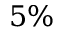Convert formula to latex. <formula><loc_0><loc_0><loc_500><loc_500>5 \%</formula> 